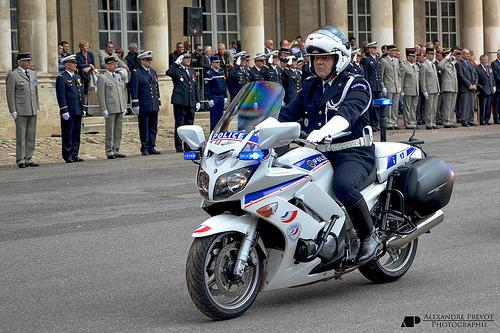Question: who is on the bike?
Choices:
A. A man.
B. Woman.
C. Child.
D. Adult.
Answer with the letter. Answer: A Question: how many people on the bike?
Choices:
A. Two.
B. Three.
C. Four.
D. One.
Answer with the letter. Answer: D Question: where is the man?
Choices:
A. The park.
B. The office.
C. The road.
D. The beach.
Answer with the letter. Answer: C Question: what does the bike say?
Choices:
A. Messenger.
B. Racer.
C. Police.
D. Rental.
Answer with the letter. Answer: C Question: why is it so bright?
Choices:
A. Lamp light.
B. Stadium light.
C. Sunny day.
D. Camera light.
Answer with the letter. Answer: C 